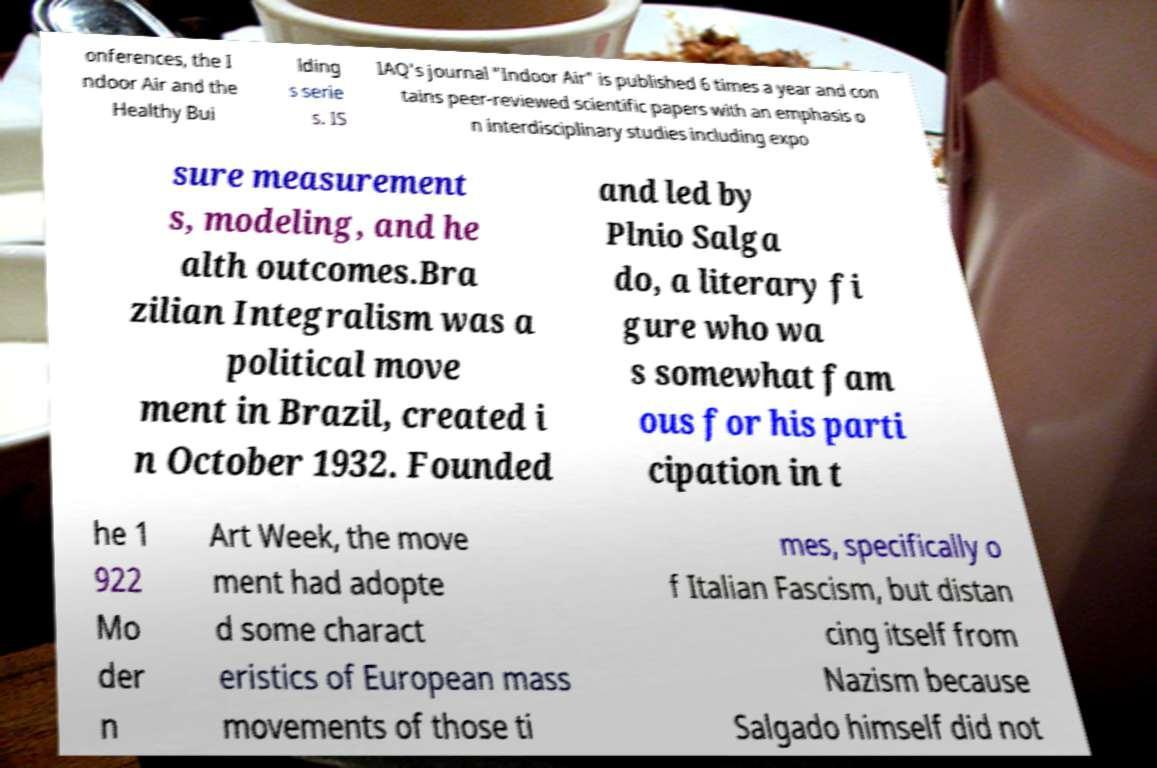Please identify and transcribe the text found in this image. onferences, the I ndoor Air and the Healthy Bui lding s serie s. IS IAQ's journal "Indoor Air" is published 6 times a year and con tains peer-reviewed scientific papers with an emphasis o n interdisciplinary studies including expo sure measurement s, modeling, and he alth outcomes.Bra zilian Integralism was a political move ment in Brazil, created i n October 1932. Founded and led by Plnio Salga do, a literary fi gure who wa s somewhat fam ous for his parti cipation in t he 1 922 Mo der n Art Week, the move ment had adopte d some charact eristics of European mass movements of those ti mes, specifically o f Italian Fascism, but distan cing itself from Nazism because Salgado himself did not 